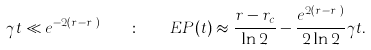Convert formula to latex. <formula><loc_0><loc_0><loc_500><loc_500>\gamma t \ll e ^ { - 2 ( r - r _ { c } ) } \quad \colon \quad E P ( t ) \approx \frac { r - r _ { c } } { \ln 2 } - \frac { e ^ { 2 ( r - r _ { c } ) } } { 2 \ln 2 } \gamma t .</formula> 